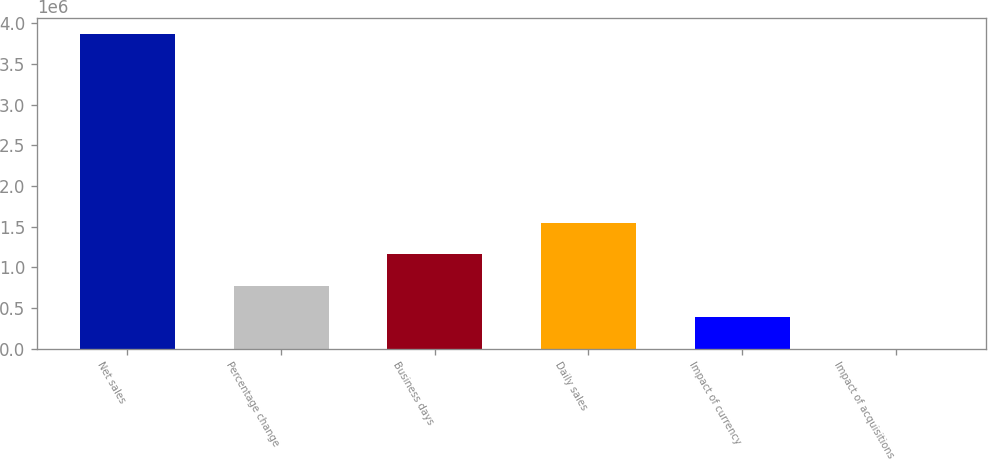Convert chart. <chart><loc_0><loc_0><loc_500><loc_500><bar_chart><fcel>Net sales<fcel>Percentage change<fcel>Business days<fcel>Daily sales<fcel>Impact of currency<fcel>Impact of acquisitions<nl><fcel>3.86919e+06<fcel>773838<fcel>1.16076e+06<fcel>1.54767e+06<fcel>386919<fcel>0.2<nl></chart> 